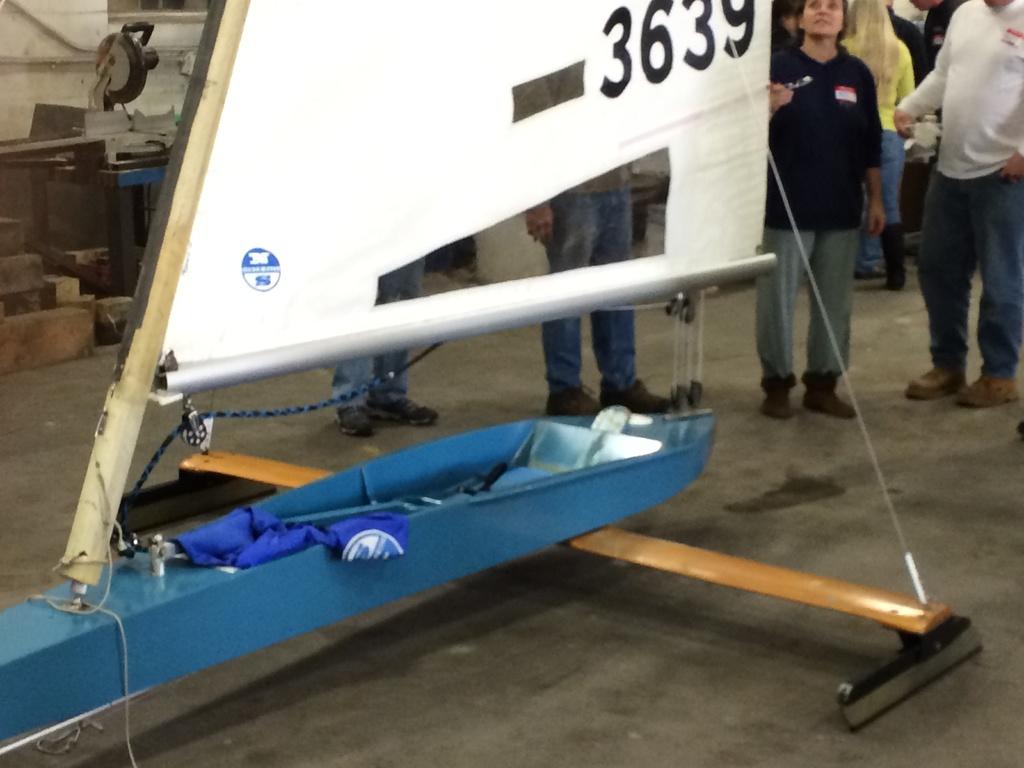What is this ships identifying number?
Your response must be concise. 3639. 